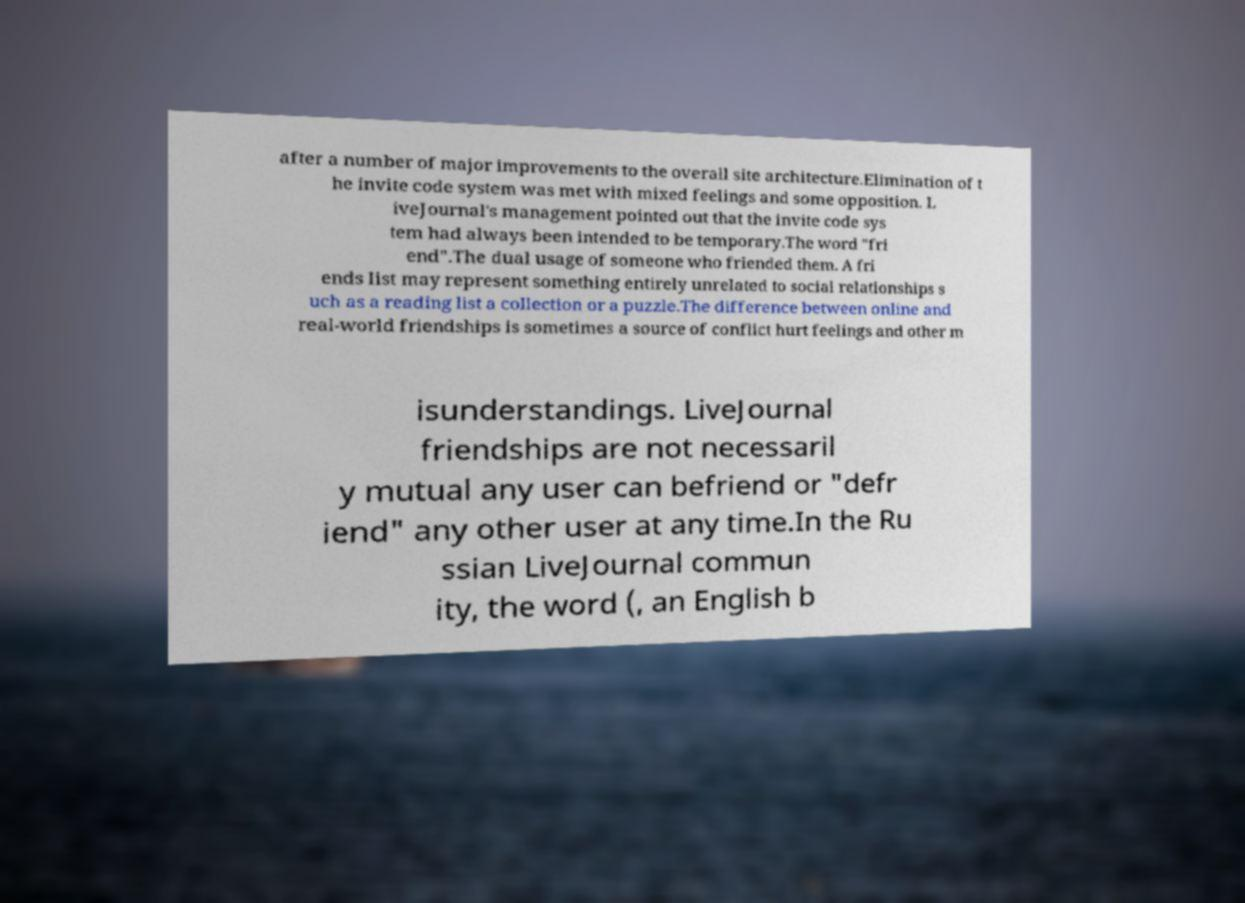For documentation purposes, I need the text within this image transcribed. Could you provide that? after a number of major improvements to the overall site architecture.Elimination of t he invite code system was met with mixed feelings and some opposition. L iveJournal's management pointed out that the invite code sys tem had always been intended to be temporary.The word "fri end".The dual usage of someone who friended them. A fri ends list may represent something entirely unrelated to social relationships s uch as a reading list a collection or a puzzle.The difference between online and real-world friendships is sometimes a source of conflict hurt feelings and other m isunderstandings. LiveJournal friendships are not necessaril y mutual any user can befriend or "defr iend" any other user at any time.In the Ru ssian LiveJournal commun ity, the word (, an English b 